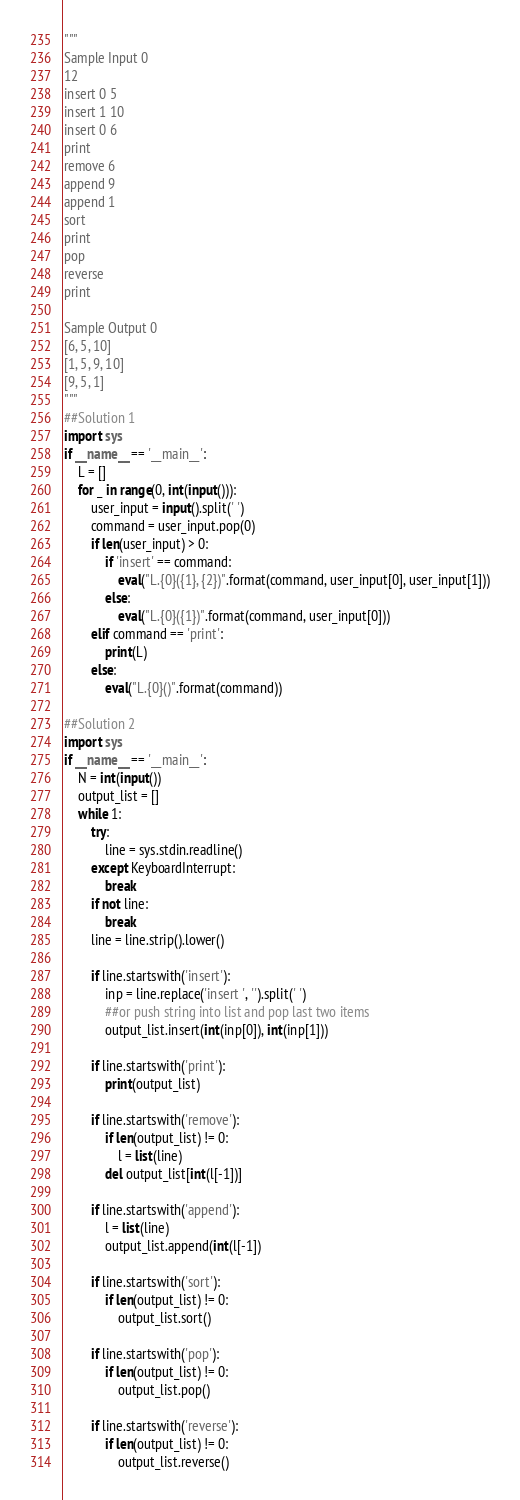<code> <loc_0><loc_0><loc_500><loc_500><_Python_>"""
Sample Input 0
12
insert 0 5
insert 1 10
insert 0 6
print
remove 6
append 9
append 1
sort
print
pop
reverse
print

Sample Output 0
[6, 5, 10]
[1, 5, 9, 10]
[9, 5, 1]
"""
##Solution 1
import sys
if __name__ == '__main__':
    L = []
    for _ in range(0, int(input())):
        user_input = input().split(' ')
        command = user_input.pop(0)
        if len(user_input) > 0:
            if 'insert' == command:
                eval("L.{0}({1}, {2})".format(command, user_input[0], user_input[1]))
            else:
                eval("L.{0}({1})".format(command, user_input[0]))
        elif command == 'print':
            print(L)
        else:
            eval("L.{0}()".format(command))

##Solution 2
import sys
if __name__ == '__main__':
    N = int(input())
    output_list = []
    while 1:
        try:
            line = sys.stdin.readline()
        except KeyboardInterrupt:
            break
        if not line:
            break
        line = line.strip().lower()
        
        if line.startswith('insert'):
            inp = line.replace('insert ', '').split(' ')
            ##or push string into list and pop last two items
            output_list.insert(int(inp[0]), int(inp[1]))
        
        if line.startswith('print'):
            print(output_list)
        
        if line.startswith('remove'):
            if len(output_list) != 0:
                l = list(line)
            del output_list[int(l[-1])]
        
        if line.startswith('append'):
            l = list(line)
            output_list.append(int(l[-1])
        
        if line.startswith('sort'):
            if len(output_list) != 0:
                output_list.sort()
        
        if line.startswith('pop'):
            if len(output_list) != 0:
                output_list.pop()
        
        if line.startswith('reverse'):
            if len(output_list) != 0:
                output_list.reverse()
</code> 